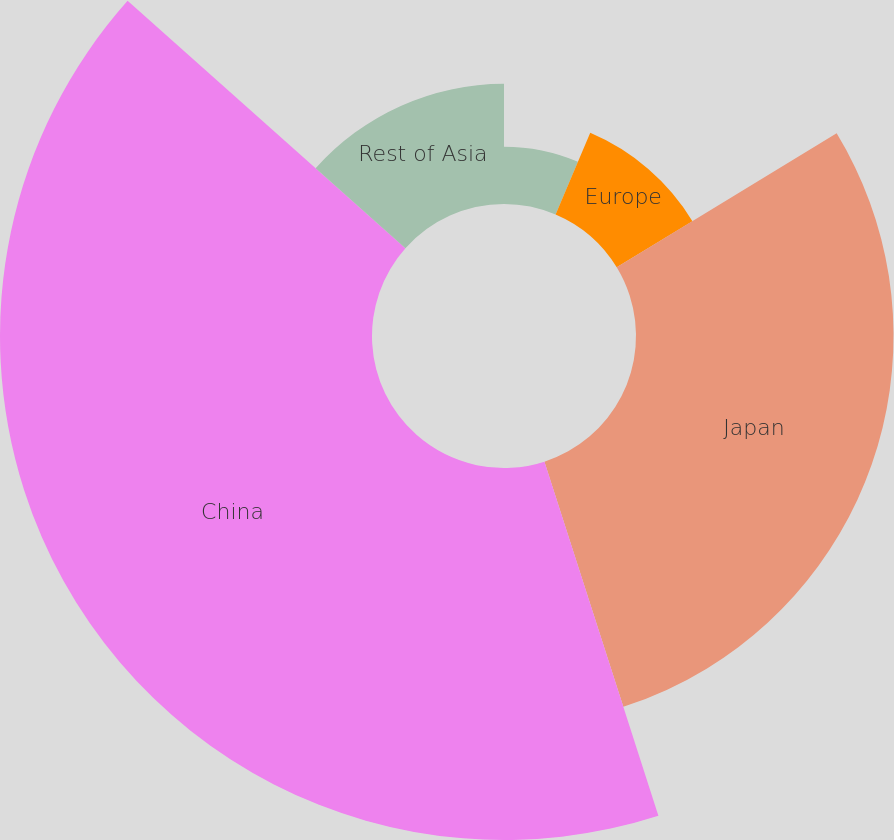Convert chart. <chart><loc_0><loc_0><loc_500><loc_500><pie_chart><fcel>United States<fcel>Europe<fcel>Japan<fcel>China<fcel>Rest of Asia<nl><fcel>6.39%<fcel>9.9%<fcel>28.75%<fcel>41.53%<fcel>13.42%<nl></chart> 